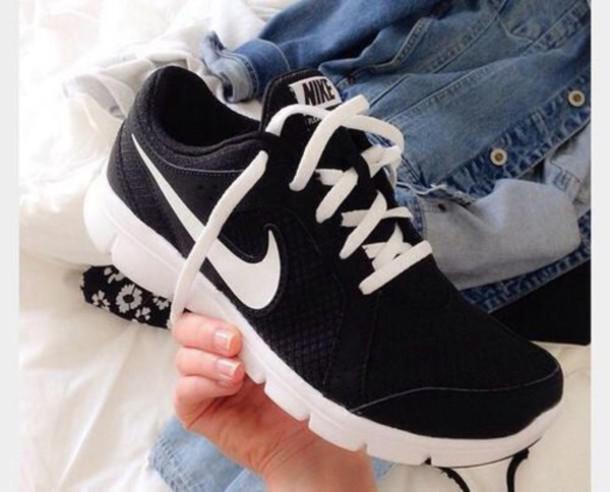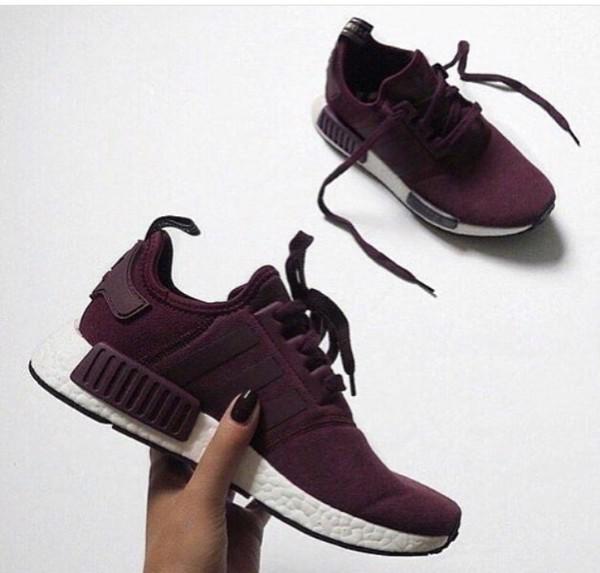The first image is the image on the left, the second image is the image on the right. Assess this claim about the two images: "There is a part of a human visible on at least one of the images.". Correct or not? Answer yes or no. Yes. 